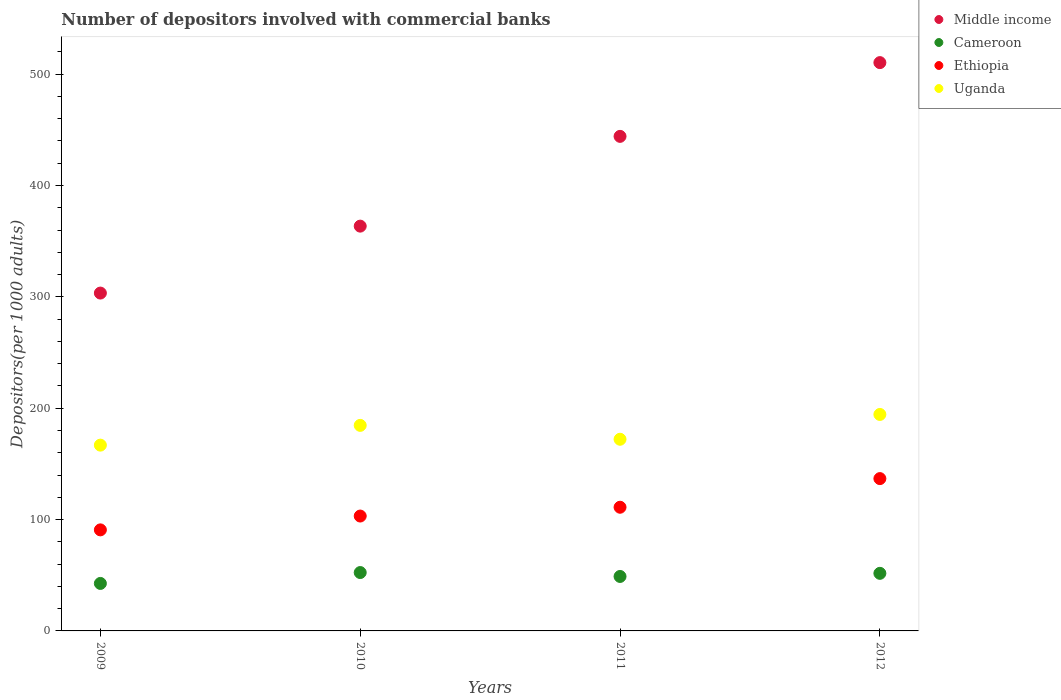How many different coloured dotlines are there?
Make the answer very short. 4. What is the number of depositors involved with commercial banks in Uganda in 2011?
Provide a succinct answer. 172.11. Across all years, what is the maximum number of depositors involved with commercial banks in Cameroon?
Your response must be concise. 52.42. Across all years, what is the minimum number of depositors involved with commercial banks in Ethiopia?
Offer a terse response. 90.74. In which year was the number of depositors involved with commercial banks in Cameroon minimum?
Your answer should be very brief. 2009. What is the total number of depositors involved with commercial banks in Ethiopia in the graph?
Give a very brief answer. 441.75. What is the difference between the number of depositors involved with commercial banks in Cameroon in 2010 and that in 2011?
Make the answer very short. 3.51. What is the difference between the number of depositors involved with commercial banks in Cameroon in 2010 and the number of depositors involved with commercial banks in Ethiopia in 2009?
Ensure brevity in your answer.  -38.32. What is the average number of depositors involved with commercial banks in Cameroon per year?
Ensure brevity in your answer.  48.92. In the year 2011, what is the difference between the number of depositors involved with commercial banks in Cameroon and number of depositors involved with commercial banks in Middle income?
Offer a very short reply. -395.2. In how many years, is the number of depositors involved with commercial banks in Ethiopia greater than 240?
Offer a very short reply. 0. What is the ratio of the number of depositors involved with commercial banks in Middle income in 2010 to that in 2012?
Ensure brevity in your answer.  0.71. Is the difference between the number of depositors involved with commercial banks in Cameroon in 2009 and 2010 greater than the difference between the number of depositors involved with commercial banks in Middle income in 2009 and 2010?
Your response must be concise. Yes. What is the difference between the highest and the second highest number of depositors involved with commercial banks in Ethiopia?
Your answer should be compact. 25.72. What is the difference between the highest and the lowest number of depositors involved with commercial banks in Ethiopia?
Your answer should be very brief. 46.05. In how many years, is the number of depositors involved with commercial banks in Uganda greater than the average number of depositors involved with commercial banks in Uganda taken over all years?
Your answer should be compact. 2. Is it the case that in every year, the sum of the number of depositors involved with commercial banks in Middle income and number of depositors involved with commercial banks in Ethiopia  is greater than the sum of number of depositors involved with commercial banks in Cameroon and number of depositors involved with commercial banks in Uganda?
Make the answer very short. No. Is it the case that in every year, the sum of the number of depositors involved with commercial banks in Uganda and number of depositors involved with commercial banks in Ethiopia  is greater than the number of depositors involved with commercial banks in Cameroon?
Provide a short and direct response. Yes. Does the number of depositors involved with commercial banks in Ethiopia monotonically increase over the years?
Offer a very short reply. Yes. Is the number of depositors involved with commercial banks in Cameroon strictly greater than the number of depositors involved with commercial banks in Middle income over the years?
Your answer should be compact. No. How many dotlines are there?
Provide a succinct answer. 4. Are the values on the major ticks of Y-axis written in scientific E-notation?
Make the answer very short. No. Does the graph contain any zero values?
Keep it short and to the point. No. Does the graph contain grids?
Offer a very short reply. No. How many legend labels are there?
Keep it short and to the point. 4. What is the title of the graph?
Offer a terse response. Number of depositors involved with commercial banks. Does "OECD members" appear as one of the legend labels in the graph?
Make the answer very short. No. What is the label or title of the X-axis?
Ensure brevity in your answer.  Years. What is the label or title of the Y-axis?
Offer a terse response. Depositors(per 1000 adults). What is the Depositors(per 1000 adults) in Middle income in 2009?
Make the answer very short. 303.38. What is the Depositors(per 1000 adults) of Cameroon in 2009?
Keep it short and to the point. 42.64. What is the Depositors(per 1000 adults) of Ethiopia in 2009?
Offer a very short reply. 90.74. What is the Depositors(per 1000 adults) of Uganda in 2009?
Make the answer very short. 166.83. What is the Depositors(per 1000 adults) of Middle income in 2010?
Keep it short and to the point. 363.5. What is the Depositors(per 1000 adults) of Cameroon in 2010?
Offer a terse response. 52.42. What is the Depositors(per 1000 adults) of Ethiopia in 2010?
Give a very brief answer. 103.16. What is the Depositors(per 1000 adults) of Uganda in 2010?
Your response must be concise. 184.58. What is the Depositors(per 1000 adults) of Middle income in 2011?
Keep it short and to the point. 444.11. What is the Depositors(per 1000 adults) of Cameroon in 2011?
Your response must be concise. 48.91. What is the Depositors(per 1000 adults) of Ethiopia in 2011?
Your answer should be compact. 111.06. What is the Depositors(per 1000 adults) in Uganda in 2011?
Your response must be concise. 172.11. What is the Depositors(per 1000 adults) in Middle income in 2012?
Keep it short and to the point. 510.34. What is the Depositors(per 1000 adults) in Cameroon in 2012?
Provide a succinct answer. 51.71. What is the Depositors(per 1000 adults) in Ethiopia in 2012?
Provide a succinct answer. 136.78. What is the Depositors(per 1000 adults) in Uganda in 2012?
Give a very brief answer. 194.39. Across all years, what is the maximum Depositors(per 1000 adults) of Middle income?
Your response must be concise. 510.34. Across all years, what is the maximum Depositors(per 1000 adults) in Cameroon?
Provide a succinct answer. 52.42. Across all years, what is the maximum Depositors(per 1000 adults) in Ethiopia?
Your response must be concise. 136.78. Across all years, what is the maximum Depositors(per 1000 adults) in Uganda?
Give a very brief answer. 194.39. Across all years, what is the minimum Depositors(per 1000 adults) in Middle income?
Provide a short and direct response. 303.38. Across all years, what is the minimum Depositors(per 1000 adults) in Cameroon?
Your response must be concise. 42.64. Across all years, what is the minimum Depositors(per 1000 adults) in Ethiopia?
Provide a short and direct response. 90.74. Across all years, what is the minimum Depositors(per 1000 adults) in Uganda?
Your answer should be very brief. 166.83. What is the total Depositors(per 1000 adults) in Middle income in the graph?
Provide a short and direct response. 1621.33. What is the total Depositors(per 1000 adults) in Cameroon in the graph?
Provide a succinct answer. 195.69. What is the total Depositors(per 1000 adults) of Ethiopia in the graph?
Keep it short and to the point. 441.75. What is the total Depositors(per 1000 adults) in Uganda in the graph?
Keep it short and to the point. 717.9. What is the difference between the Depositors(per 1000 adults) in Middle income in 2009 and that in 2010?
Offer a very short reply. -60.11. What is the difference between the Depositors(per 1000 adults) in Cameroon in 2009 and that in 2010?
Your response must be concise. -9.78. What is the difference between the Depositors(per 1000 adults) of Ethiopia in 2009 and that in 2010?
Make the answer very short. -12.42. What is the difference between the Depositors(per 1000 adults) in Uganda in 2009 and that in 2010?
Keep it short and to the point. -17.75. What is the difference between the Depositors(per 1000 adults) of Middle income in 2009 and that in 2011?
Your response must be concise. -140.73. What is the difference between the Depositors(per 1000 adults) in Cameroon in 2009 and that in 2011?
Your answer should be compact. -6.27. What is the difference between the Depositors(per 1000 adults) of Ethiopia in 2009 and that in 2011?
Your response must be concise. -20.33. What is the difference between the Depositors(per 1000 adults) in Uganda in 2009 and that in 2011?
Keep it short and to the point. -5.28. What is the difference between the Depositors(per 1000 adults) in Middle income in 2009 and that in 2012?
Keep it short and to the point. -206.95. What is the difference between the Depositors(per 1000 adults) in Cameroon in 2009 and that in 2012?
Your answer should be compact. -9.07. What is the difference between the Depositors(per 1000 adults) of Ethiopia in 2009 and that in 2012?
Offer a terse response. -46.05. What is the difference between the Depositors(per 1000 adults) in Uganda in 2009 and that in 2012?
Ensure brevity in your answer.  -27.56. What is the difference between the Depositors(per 1000 adults) of Middle income in 2010 and that in 2011?
Make the answer very short. -80.61. What is the difference between the Depositors(per 1000 adults) in Cameroon in 2010 and that in 2011?
Offer a very short reply. 3.51. What is the difference between the Depositors(per 1000 adults) in Ethiopia in 2010 and that in 2011?
Provide a succinct answer. -7.91. What is the difference between the Depositors(per 1000 adults) of Uganda in 2010 and that in 2011?
Make the answer very short. 12.47. What is the difference between the Depositors(per 1000 adults) in Middle income in 2010 and that in 2012?
Ensure brevity in your answer.  -146.84. What is the difference between the Depositors(per 1000 adults) in Cameroon in 2010 and that in 2012?
Make the answer very short. 0.71. What is the difference between the Depositors(per 1000 adults) of Ethiopia in 2010 and that in 2012?
Your answer should be compact. -33.63. What is the difference between the Depositors(per 1000 adults) of Uganda in 2010 and that in 2012?
Provide a short and direct response. -9.81. What is the difference between the Depositors(per 1000 adults) in Middle income in 2011 and that in 2012?
Offer a terse response. -66.23. What is the difference between the Depositors(per 1000 adults) in Cameroon in 2011 and that in 2012?
Give a very brief answer. -2.8. What is the difference between the Depositors(per 1000 adults) in Ethiopia in 2011 and that in 2012?
Provide a succinct answer. -25.72. What is the difference between the Depositors(per 1000 adults) in Uganda in 2011 and that in 2012?
Your answer should be compact. -22.28. What is the difference between the Depositors(per 1000 adults) of Middle income in 2009 and the Depositors(per 1000 adults) of Cameroon in 2010?
Your answer should be very brief. 250.96. What is the difference between the Depositors(per 1000 adults) in Middle income in 2009 and the Depositors(per 1000 adults) in Ethiopia in 2010?
Make the answer very short. 200.23. What is the difference between the Depositors(per 1000 adults) in Middle income in 2009 and the Depositors(per 1000 adults) in Uganda in 2010?
Offer a very short reply. 118.8. What is the difference between the Depositors(per 1000 adults) in Cameroon in 2009 and the Depositors(per 1000 adults) in Ethiopia in 2010?
Give a very brief answer. -60.51. What is the difference between the Depositors(per 1000 adults) of Cameroon in 2009 and the Depositors(per 1000 adults) of Uganda in 2010?
Your answer should be very brief. -141.94. What is the difference between the Depositors(per 1000 adults) of Ethiopia in 2009 and the Depositors(per 1000 adults) of Uganda in 2010?
Ensure brevity in your answer.  -93.84. What is the difference between the Depositors(per 1000 adults) in Middle income in 2009 and the Depositors(per 1000 adults) in Cameroon in 2011?
Provide a short and direct response. 254.47. What is the difference between the Depositors(per 1000 adults) of Middle income in 2009 and the Depositors(per 1000 adults) of Ethiopia in 2011?
Provide a short and direct response. 192.32. What is the difference between the Depositors(per 1000 adults) of Middle income in 2009 and the Depositors(per 1000 adults) of Uganda in 2011?
Give a very brief answer. 131.28. What is the difference between the Depositors(per 1000 adults) in Cameroon in 2009 and the Depositors(per 1000 adults) in Ethiopia in 2011?
Your answer should be very brief. -68.42. What is the difference between the Depositors(per 1000 adults) in Cameroon in 2009 and the Depositors(per 1000 adults) in Uganda in 2011?
Provide a succinct answer. -129.46. What is the difference between the Depositors(per 1000 adults) of Ethiopia in 2009 and the Depositors(per 1000 adults) of Uganda in 2011?
Your answer should be very brief. -81.37. What is the difference between the Depositors(per 1000 adults) in Middle income in 2009 and the Depositors(per 1000 adults) in Cameroon in 2012?
Offer a terse response. 251.67. What is the difference between the Depositors(per 1000 adults) in Middle income in 2009 and the Depositors(per 1000 adults) in Ethiopia in 2012?
Your answer should be very brief. 166.6. What is the difference between the Depositors(per 1000 adults) of Middle income in 2009 and the Depositors(per 1000 adults) of Uganda in 2012?
Offer a very short reply. 109. What is the difference between the Depositors(per 1000 adults) in Cameroon in 2009 and the Depositors(per 1000 adults) in Ethiopia in 2012?
Make the answer very short. -94.14. What is the difference between the Depositors(per 1000 adults) in Cameroon in 2009 and the Depositors(per 1000 adults) in Uganda in 2012?
Your response must be concise. -151.74. What is the difference between the Depositors(per 1000 adults) in Ethiopia in 2009 and the Depositors(per 1000 adults) in Uganda in 2012?
Your response must be concise. -103.65. What is the difference between the Depositors(per 1000 adults) in Middle income in 2010 and the Depositors(per 1000 adults) in Cameroon in 2011?
Provide a short and direct response. 314.59. What is the difference between the Depositors(per 1000 adults) in Middle income in 2010 and the Depositors(per 1000 adults) in Ethiopia in 2011?
Your answer should be very brief. 252.43. What is the difference between the Depositors(per 1000 adults) in Middle income in 2010 and the Depositors(per 1000 adults) in Uganda in 2011?
Give a very brief answer. 191.39. What is the difference between the Depositors(per 1000 adults) in Cameroon in 2010 and the Depositors(per 1000 adults) in Ethiopia in 2011?
Ensure brevity in your answer.  -58.64. What is the difference between the Depositors(per 1000 adults) in Cameroon in 2010 and the Depositors(per 1000 adults) in Uganda in 2011?
Offer a very short reply. -119.68. What is the difference between the Depositors(per 1000 adults) of Ethiopia in 2010 and the Depositors(per 1000 adults) of Uganda in 2011?
Make the answer very short. -68.95. What is the difference between the Depositors(per 1000 adults) in Middle income in 2010 and the Depositors(per 1000 adults) in Cameroon in 2012?
Offer a terse response. 311.79. What is the difference between the Depositors(per 1000 adults) in Middle income in 2010 and the Depositors(per 1000 adults) in Ethiopia in 2012?
Give a very brief answer. 226.71. What is the difference between the Depositors(per 1000 adults) in Middle income in 2010 and the Depositors(per 1000 adults) in Uganda in 2012?
Your response must be concise. 169.11. What is the difference between the Depositors(per 1000 adults) of Cameroon in 2010 and the Depositors(per 1000 adults) of Ethiopia in 2012?
Offer a terse response. -84.36. What is the difference between the Depositors(per 1000 adults) of Cameroon in 2010 and the Depositors(per 1000 adults) of Uganda in 2012?
Your answer should be compact. -141.97. What is the difference between the Depositors(per 1000 adults) of Ethiopia in 2010 and the Depositors(per 1000 adults) of Uganda in 2012?
Provide a succinct answer. -91.23. What is the difference between the Depositors(per 1000 adults) in Middle income in 2011 and the Depositors(per 1000 adults) in Cameroon in 2012?
Offer a terse response. 392.4. What is the difference between the Depositors(per 1000 adults) in Middle income in 2011 and the Depositors(per 1000 adults) in Ethiopia in 2012?
Provide a short and direct response. 307.33. What is the difference between the Depositors(per 1000 adults) of Middle income in 2011 and the Depositors(per 1000 adults) of Uganda in 2012?
Your answer should be compact. 249.72. What is the difference between the Depositors(per 1000 adults) in Cameroon in 2011 and the Depositors(per 1000 adults) in Ethiopia in 2012?
Provide a succinct answer. -87.87. What is the difference between the Depositors(per 1000 adults) of Cameroon in 2011 and the Depositors(per 1000 adults) of Uganda in 2012?
Your answer should be compact. -145.48. What is the difference between the Depositors(per 1000 adults) in Ethiopia in 2011 and the Depositors(per 1000 adults) in Uganda in 2012?
Ensure brevity in your answer.  -83.32. What is the average Depositors(per 1000 adults) of Middle income per year?
Offer a very short reply. 405.33. What is the average Depositors(per 1000 adults) of Cameroon per year?
Offer a terse response. 48.92. What is the average Depositors(per 1000 adults) in Ethiopia per year?
Keep it short and to the point. 110.44. What is the average Depositors(per 1000 adults) in Uganda per year?
Ensure brevity in your answer.  179.48. In the year 2009, what is the difference between the Depositors(per 1000 adults) in Middle income and Depositors(per 1000 adults) in Cameroon?
Your answer should be very brief. 260.74. In the year 2009, what is the difference between the Depositors(per 1000 adults) of Middle income and Depositors(per 1000 adults) of Ethiopia?
Provide a succinct answer. 212.64. In the year 2009, what is the difference between the Depositors(per 1000 adults) in Middle income and Depositors(per 1000 adults) in Uganda?
Ensure brevity in your answer.  136.55. In the year 2009, what is the difference between the Depositors(per 1000 adults) of Cameroon and Depositors(per 1000 adults) of Ethiopia?
Make the answer very short. -48.1. In the year 2009, what is the difference between the Depositors(per 1000 adults) of Cameroon and Depositors(per 1000 adults) of Uganda?
Ensure brevity in your answer.  -124.19. In the year 2009, what is the difference between the Depositors(per 1000 adults) of Ethiopia and Depositors(per 1000 adults) of Uganda?
Keep it short and to the point. -76.09. In the year 2010, what is the difference between the Depositors(per 1000 adults) of Middle income and Depositors(per 1000 adults) of Cameroon?
Offer a terse response. 311.07. In the year 2010, what is the difference between the Depositors(per 1000 adults) in Middle income and Depositors(per 1000 adults) in Ethiopia?
Provide a short and direct response. 260.34. In the year 2010, what is the difference between the Depositors(per 1000 adults) in Middle income and Depositors(per 1000 adults) in Uganda?
Your response must be concise. 178.92. In the year 2010, what is the difference between the Depositors(per 1000 adults) of Cameroon and Depositors(per 1000 adults) of Ethiopia?
Provide a succinct answer. -50.74. In the year 2010, what is the difference between the Depositors(per 1000 adults) in Cameroon and Depositors(per 1000 adults) in Uganda?
Your response must be concise. -132.16. In the year 2010, what is the difference between the Depositors(per 1000 adults) of Ethiopia and Depositors(per 1000 adults) of Uganda?
Provide a succinct answer. -81.42. In the year 2011, what is the difference between the Depositors(per 1000 adults) of Middle income and Depositors(per 1000 adults) of Cameroon?
Provide a short and direct response. 395.2. In the year 2011, what is the difference between the Depositors(per 1000 adults) in Middle income and Depositors(per 1000 adults) in Ethiopia?
Offer a terse response. 333.05. In the year 2011, what is the difference between the Depositors(per 1000 adults) of Middle income and Depositors(per 1000 adults) of Uganda?
Make the answer very short. 272. In the year 2011, what is the difference between the Depositors(per 1000 adults) of Cameroon and Depositors(per 1000 adults) of Ethiopia?
Give a very brief answer. -62.15. In the year 2011, what is the difference between the Depositors(per 1000 adults) in Cameroon and Depositors(per 1000 adults) in Uganda?
Keep it short and to the point. -123.2. In the year 2011, what is the difference between the Depositors(per 1000 adults) of Ethiopia and Depositors(per 1000 adults) of Uganda?
Your answer should be very brief. -61.04. In the year 2012, what is the difference between the Depositors(per 1000 adults) in Middle income and Depositors(per 1000 adults) in Cameroon?
Keep it short and to the point. 458.63. In the year 2012, what is the difference between the Depositors(per 1000 adults) of Middle income and Depositors(per 1000 adults) of Ethiopia?
Offer a terse response. 373.55. In the year 2012, what is the difference between the Depositors(per 1000 adults) in Middle income and Depositors(per 1000 adults) in Uganda?
Your response must be concise. 315.95. In the year 2012, what is the difference between the Depositors(per 1000 adults) in Cameroon and Depositors(per 1000 adults) in Ethiopia?
Your answer should be very brief. -85.07. In the year 2012, what is the difference between the Depositors(per 1000 adults) of Cameroon and Depositors(per 1000 adults) of Uganda?
Provide a short and direct response. -142.68. In the year 2012, what is the difference between the Depositors(per 1000 adults) of Ethiopia and Depositors(per 1000 adults) of Uganda?
Offer a terse response. -57.6. What is the ratio of the Depositors(per 1000 adults) of Middle income in 2009 to that in 2010?
Provide a succinct answer. 0.83. What is the ratio of the Depositors(per 1000 adults) of Cameroon in 2009 to that in 2010?
Make the answer very short. 0.81. What is the ratio of the Depositors(per 1000 adults) of Ethiopia in 2009 to that in 2010?
Make the answer very short. 0.88. What is the ratio of the Depositors(per 1000 adults) of Uganda in 2009 to that in 2010?
Give a very brief answer. 0.9. What is the ratio of the Depositors(per 1000 adults) in Middle income in 2009 to that in 2011?
Your answer should be very brief. 0.68. What is the ratio of the Depositors(per 1000 adults) in Cameroon in 2009 to that in 2011?
Keep it short and to the point. 0.87. What is the ratio of the Depositors(per 1000 adults) in Ethiopia in 2009 to that in 2011?
Ensure brevity in your answer.  0.82. What is the ratio of the Depositors(per 1000 adults) in Uganda in 2009 to that in 2011?
Your answer should be very brief. 0.97. What is the ratio of the Depositors(per 1000 adults) in Middle income in 2009 to that in 2012?
Provide a short and direct response. 0.59. What is the ratio of the Depositors(per 1000 adults) in Cameroon in 2009 to that in 2012?
Your response must be concise. 0.82. What is the ratio of the Depositors(per 1000 adults) of Ethiopia in 2009 to that in 2012?
Make the answer very short. 0.66. What is the ratio of the Depositors(per 1000 adults) in Uganda in 2009 to that in 2012?
Offer a terse response. 0.86. What is the ratio of the Depositors(per 1000 adults) of Middle income in 2010 to that in 2011?
Your response must be concise. 0.82. What is the ratio of the Depositors(per 1000 adults) of Cameroon in 2010 to that in 2011?
Your answer should be very brief. 1.07. What is the ratio of the Depositors(per 1000 adults) in Ethiopia in 2010 to that in 2011?
Your answer should be compact. 0.93. What is the ratio of the Depositors(per 1000 adults) of Uganda in 2010 to that in 2011?
Offer a very short reply. 1.07. What is the ratio of the Depositors(per 1000 adults) of Middle income in 2010 to that in 2012?
Ensure brevity in your answer.  0.71. What is the ratio of the Depositors(per 1000 adults) in Cameroon in 2010 to that in 2012?
Offer a terse response. 1.01. What is the ratio of the Depositors(per 1000 adults) in Ethiopia in 2010 to that in 2012?
Offer a terse response. 0.75. What is the ratio of the Depositors(per 1000 adults) in Uganda in 2010 to that in 2012?
Ensure brevity in your answer.  0.95. What is the ratio of the Depositors(per 1000 adults) of Middle income in 2011 to that in 2012?
Your answer should be compact. 0.87. What is the ratio of the Depositors(per 1000 adults) in Cameroon in 2011 to that in 2012?
Offer a terse response. 0.95. What is the ratio of the Depositors(per 1000 adults) in Ethiopia in 2011 to that in 2012?
Offer a terse response. 0.81. What is the ratio of the Depositors(per 1000 adults) in Uganda in 2011 to that in 2012?
Offer a very short reply. 0.89. What is the difference between the highest and the second highest Depositors(per 1000 adults) in Middle income?
Ensure brevity in your answer.  66.23. What is the difference between the highest and the second highest Depositors(per 1000 adults) of Cameroon?
Keep it short and to the point. 0.71. What is the difference between the highest and the second highest Depositors(per 1000 adults) in Ethiopia?
Your response must be concise. 25.72. What is the difference between the highest and the second highest Depositors(per 1000 adults) of Uganda?
Your response must be concise. 9.81. What is the difference between the highest and the lowest Depositors(per 1000 adults) of Middle income?
Ensure brevity in your answer.  206.95. What is the difference between the highest and the lowest Depositors(per 1000 adults) of Cameroon?
Your answer should be compact. 9.78. What is the difference between the highest and the lowest Depositors(per 1000 adults) in Ethiopia?
Provide a short and direct response. 46.05. What is the difference between the highest and the lowest Depositors(per 1000 adults) of Uganda?
Your answer should be very brief. 27.56. 